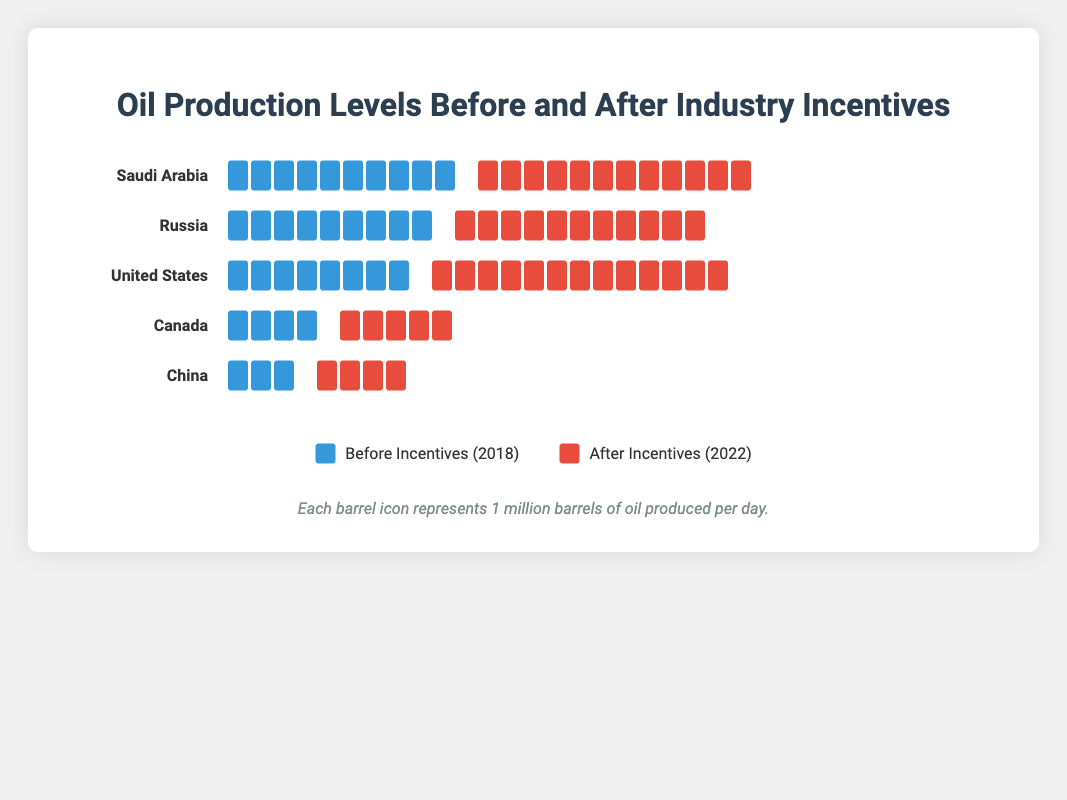How much did oil production in Saudi Arabia increase after the industry incentives were implemented? Saudi Arabia's production increased from 10 million barrels per day to 12 million barrels per day, which is an increase of 2 million barrels per day.
Answer: 2 million barrels per day Which country saw the largest absolute increase in oil production after the incentives were applied? The United States increased production from 8 million barrels per day to 13 million barrels per day, an increase of 5 million barrels per day.
Answer: United States In which country was the increase in oil production the smallest after implementing the incentives? Canada saw an increase from 4 million barrels per day to 5 million barrels per day, which is an increase of 1 million barrels per day.
Answer: Canada What was the total oil production for all countries combined before implementing the incentives? Summing the production values before incentives: 10 (Saudi Arabia) + 9 (Russia) + 8 (United States) + 4 (Canada) + 3 (China) = 34 million barrels per day.
Answer: 34 million barrels per day What was the difference in oil production between Russia and China after implementing the incentives? Russia produced 11 million barrels per day after incentives, and China produced 4 million barrels per day. The difference is 11 - 4 = 7 million barrels per day.
Answer: 7 million barrels per day Between 2018 and 2022, which country showed the highest percent increase in oil production? United States increased from 8 to 13 million barrels per day. The percentage increase is ((13 - 8) / 8) * 100 = 62.5%.
Answer: United States How many barrels does each icon represent, and how is this indicated in the figure? Each icon represents 1 million barrels of oil produced per day, as noted in the footnote at the bottom of the figure.
Answer: 1 million barrels Which two countries had the same increase in oil production levels after the incentives? Both Russia and Saudi Arabia saw an increase of 2 million barrels per day after the incentives, increasing from 9 to 11 and 10 to 12 million barrels per day, respectively.
Answer: Russia and Saudi Arabia By how much did China's oil production increase as compared to Canada's increase? China's production increased by 1 million barrels per day (from 3 to 4), while Canada’s increase was also 1 million barrels per day (from 4 to 5), so both had the same increase.
Answer: Same What's the total oil production for all countries combined after implementing the incentives? Summing the production values after incentives: 12 (Saudi Arabia) + 11 (Russia) + 13 (United States) + 5 (Canada) + 4 (China) = 45 million barrels per day.
Answer: 45 million barrels per day 